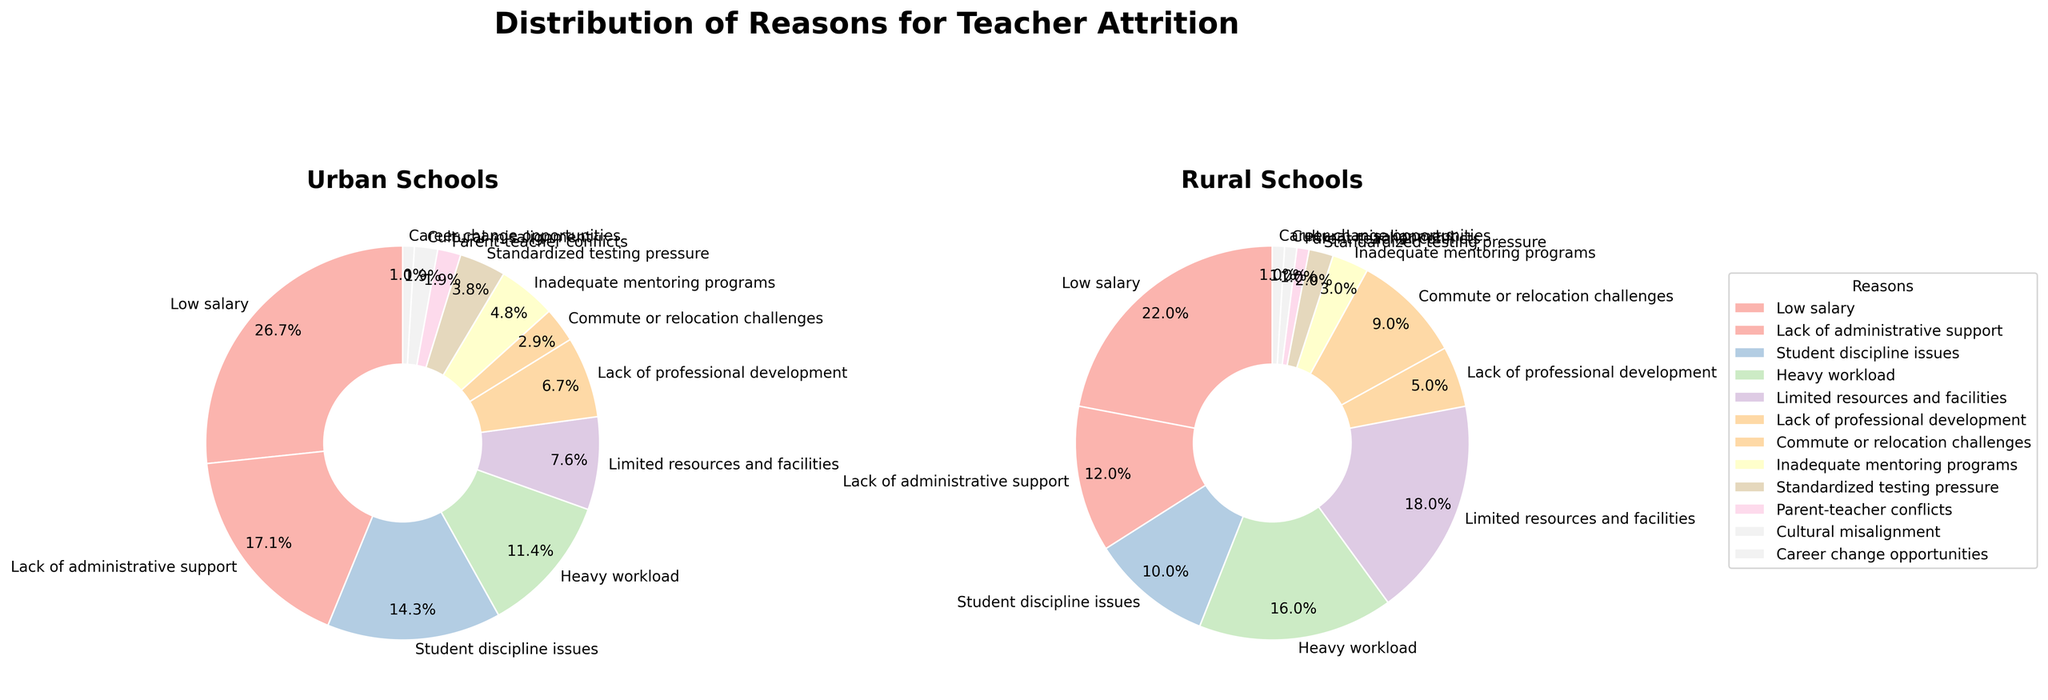What is the most common reason for teacher attrition in urban schools? By examining the percentages for each reason in urban schools, the highest percentage is 28% for "Low salary."
Answer: "Low salary" Which reason has a higher percentage in rural schools compared to urban schools? Compare the percentages for each reason in rural and urban schools. "Limited resources and facilities" is 18% in rural vs. 8% in urban, which is higher.
Answer: "Limited resources and facilities" How much more common is "Student discipline issues" as a reason for teacher attrition in urban schools compared to rural schools? Look at the percentages for "Student discipline issues" in both urban (15%) and rural (10%) schools and compute the difference: 15% - 10% = 5%.
Answer: 5% What is the combined percentage of attrition reasons related to workload issues (such as "Heavy workload" and "Limited resources and facilities") in rural schools? Add the percentages for "Heavy workload" (16%) and "Limited resources and facilities" (18%) in rural schools: 16% + 18% = 34%.
Answer: 34% Which reason has the smallest percentage in both urban and rural schools? Compare the percentages for each reason in urban and rural schools; "Career change opportunities" has 1% in both.
Answer: "Career change opportunities" In the pie chart for rural schools, which reasons would be combined to reach over 30% of teacher attrition? Identify reasons and their percentages in rural schools: "Limited resources and facilities" (18%) and "Heavy workload" (16%) sum up to more than 30%.
Answer: "Limited resources and facilities" and "Heavy workload" Is "Lack of administrative support" a more significant issue in urban schools or rural schools? Compare the percentage for "Lack of administrative support" in urban (18%) and rural (12%) schools. The percentage is higher in urban schools.
Answer: Urban schools What visual attributes distinguish the pie charts for urban and rural schools? Note the different segments' sizes and their labels. For example, urban schools have a larger segment for "Low salary," while rural schools have a noticeable segment for "Limited resources and facilities."
Answer: Segment sizes and labels Which reason holds the same percentage for both urban and rural schools? Look for any reason with an equal percentage in both charts; "Career change opportunities" is 1% in both.
Answer: "Career change opportunities" Between "Commute or relocation challenges" and "Inadequate mentoring programs," which is more common in rural schools? Compare the percentages for "Commute or relocation challenges" (9%) and "Inadequate mentoring programs" (3%) in rural schools. "Commute or relocation challenges" has a higher percentage.
Answer: "Commute or relocation challenges" 